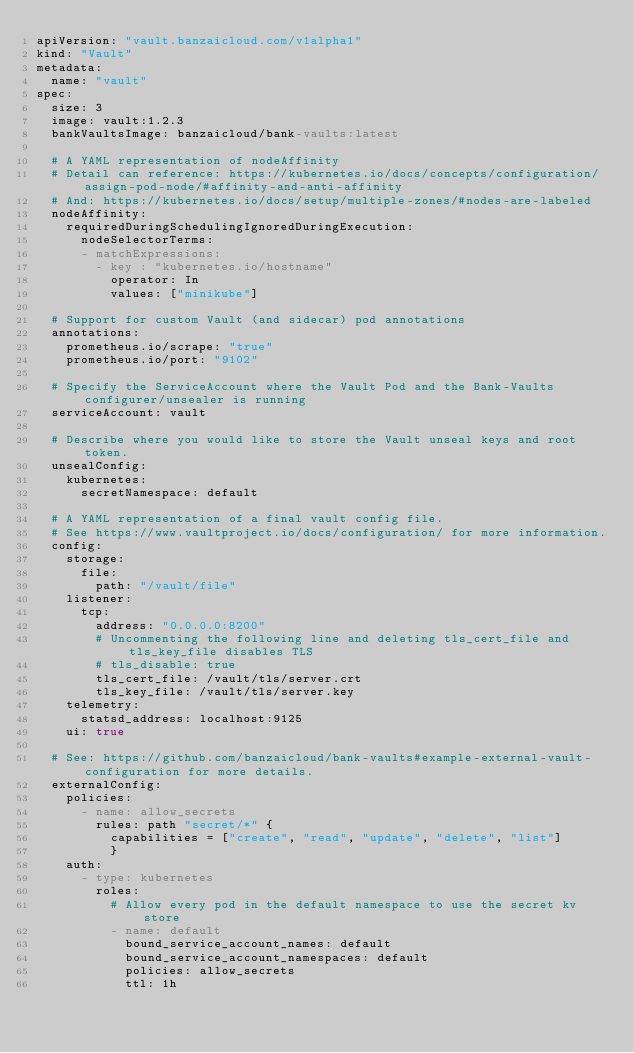Convert code to text. <code><loc_0><loc_0><loc_500><loc_500><_YAML_>apiVersion: "vault.banzaicloud.com/v1alpha1"
kind: "Vault"
metadata:
  name: "vault"
spec:
  size: 3
  image: vault:1.2.3
  bankVaultsImage: banzaicloud/bank-vaults:latest

  # A YAML representation of nodeAffinity
  # Detail can reference: https://kubernetes.io/docs/concepts/configuration/assign-pod-node/#affinity-and-anti-affinity
  # And: https://kubernetes.io/docs/setup/multiple-zones/#nodes-are-labeled
  nodeAffinity:
    requiredDuringSchedulingIgnoredDuringExecution:
      nodeSelectorTerms:
      - matchExpressions:
        - key : "kubernetes.io/hostname"
          operator: In
          values: ["minikube"]

  # Support for custom Vault (and sidecar) pod annotations
  annotations:
    prometheus.io/scrape: "true"
    prometheus.io/port: "9102"

  # Specify the ServiceAccount where the Vault Pod and the Bank-Vaults configurer/unsealer is running
  serviceAccount: vault

  # Describe where you would like to store the Vault unseal keys and root token.
  unsealConfig:
    kubernetes:
      secretNamespace: default

  # A YAML representation of a final vault config file.
  # See https://www.vaultproject.io/docs/configuration/ for more information.
  config:
    storage:
      file:
        path: "/vault/file"
    listener:
      tcp:
        address: "0.0.0.0:8200"
        # Uncommenting the following line and deleting tls_cert_file and tls_key_file disables TLS
        # tls_disable: true
        tls_cert_file: /vault/tls/server.crt
        tls_key_file: /vault/tls/server.key
    telemetry:
      statsd_address: localhost:9125
    ui: true

  # See: https://github.com/banzaicloud/bank-vaults#example-external-vault-configuration for more details.
  externalConfig:
    policies:
      - name: allow_secrets
        rules: path "secret/*" {
          capabilities = ["create", "read", "update", "delete", "list"]
          }
    auth:
      - type: kubernetes
        roles:
          # Allow every pod in the default namespace to use the secret kv store
          - name: default
            bound_service_account_names: default
            bound_service_account_namespaces: default
            policies: allow_secrets
            ttl: 1h
</code> 